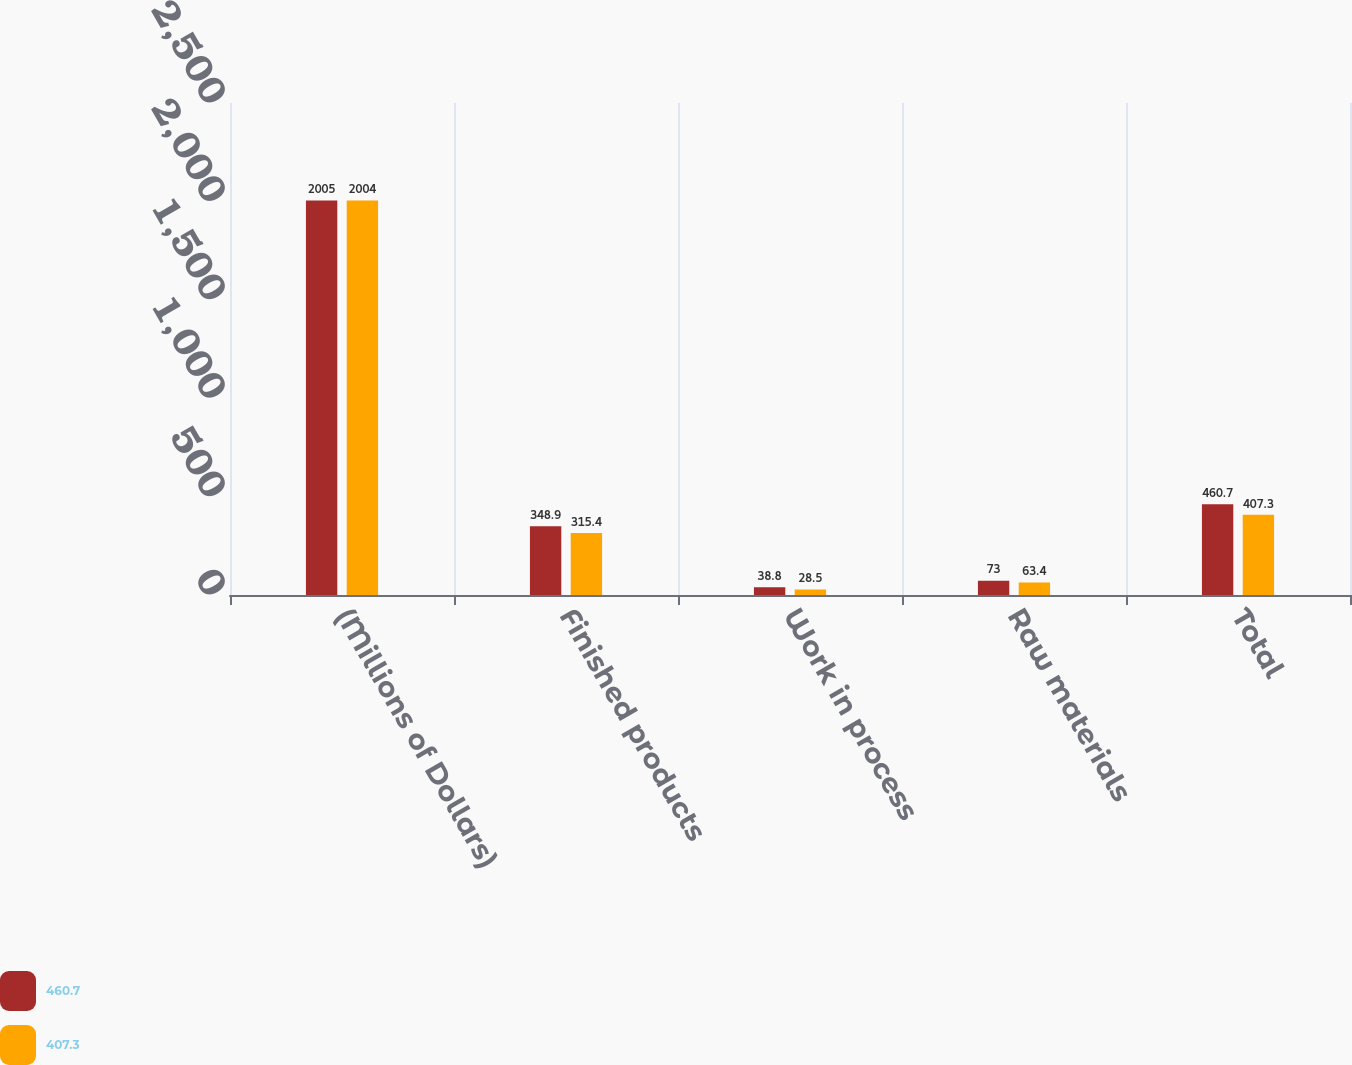Convert chart to OTSL. <chart><loc_0><loc_0><loc_500><loc_500><stacked_bar_chart><ecel><fcel>(Millions of Dollars)<fcel>Finished products<fcel>Work in process<fcel>Raw materials<fcel>Total<nl><fcel>460.7<fcel>2005<fcel>348.9<fcel>38.8<fcel>73<fcel>460.7<nl><fcel>407.3<fcel>2004<fcel>315.4<fcel>28.5<fcel>63.4<fcel>407.3<nl></chart> 